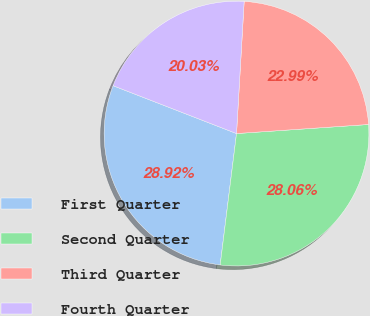Convert chart. <chart><loc_0><loc_0><loc_500><loc_500><pie_chart><fcel>First Quarter<fcel>Second Quarter<fcel>Third Quarter<fcel>Fourth Quarter<nl><fcel>28.92%<fcel>28.06%<fcel>22.99%<fcel>20.03%<nl></chart> 